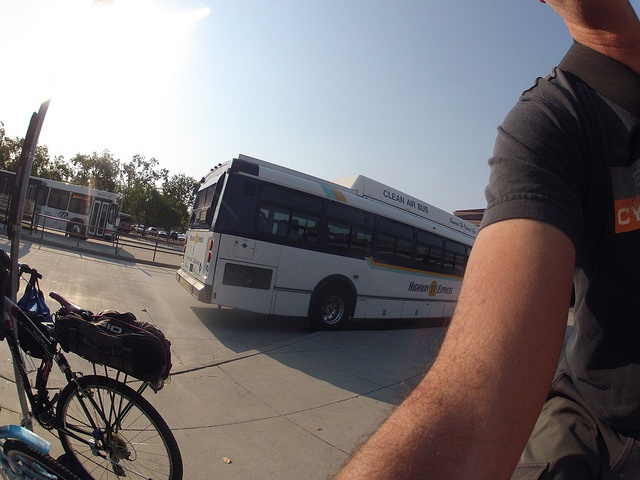Describe the objects in this image and their specific colors. I can see people in white, black, maroon, brown, and gray tones, bus in white, black, gray, and darkgray tones, bicycle in white, black, gray, and darkgray tones, bus in white, black, and gray tones, and backpack in white, black, gray, and darkgray tones in this image. 